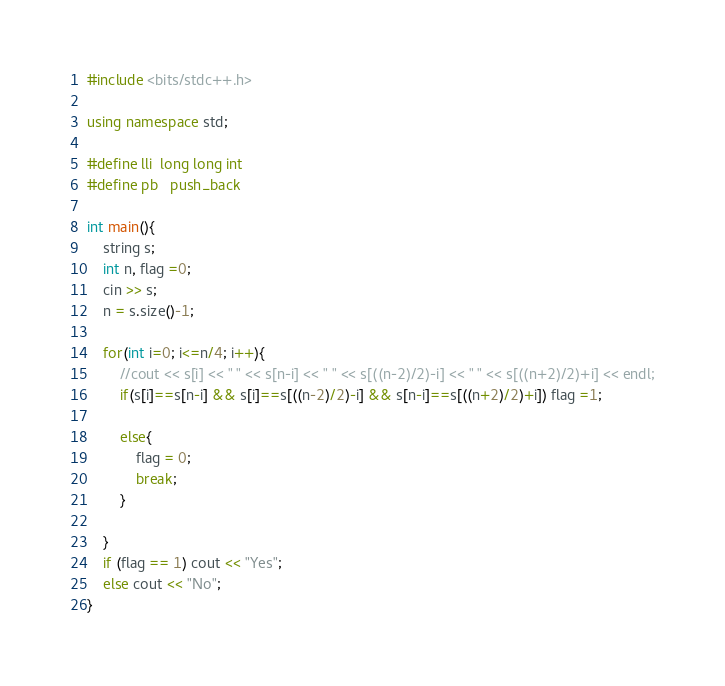Convert code to text. <code><loc_0><loc_0><loc_500><loc_500><_C++_>#include <bits/stdc++.h>

using namespace std;

#define lli  long long int
#define pb   push_back

int main(){
    string s;
    int n, flag =0;
    cin >> s;
    n = s.size()-1;

    for(int i=0; i<=n/4; i++){
        //cout << s[i] << " " << s[n-i] << " " << s[((n-2)/2)-i] << " " << s[((n+2)/2)+i] << endl;
        if(s[i]==s[n-i] && s[i]==s[((n-2)/2)-i] && s[n-i]==s[((n+2)/2)+i]) flag =1;

        else{
            flag = 0;
            break;
        }

    }
    if (flag == 1) cout << "Yes";
    else cout << "No";
}</code> 